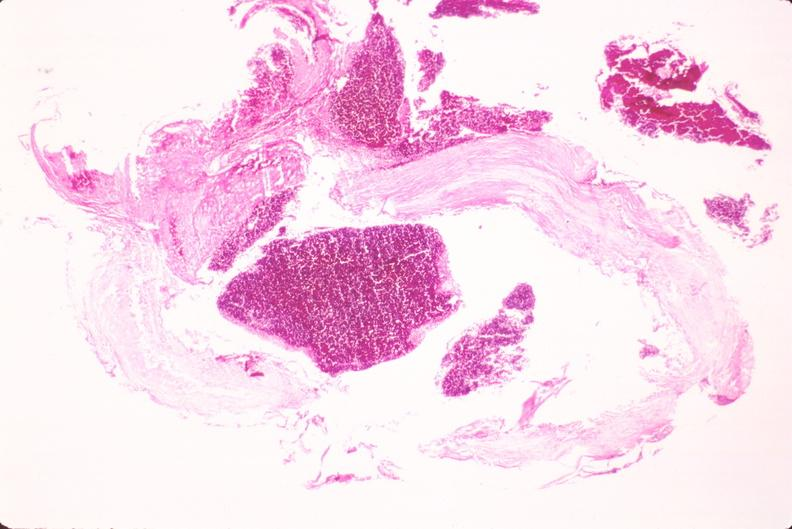does polycystic disease show ruptured saccular aneurysm right middle cerebral artery?
Answer the question using a single word or phrase. No 